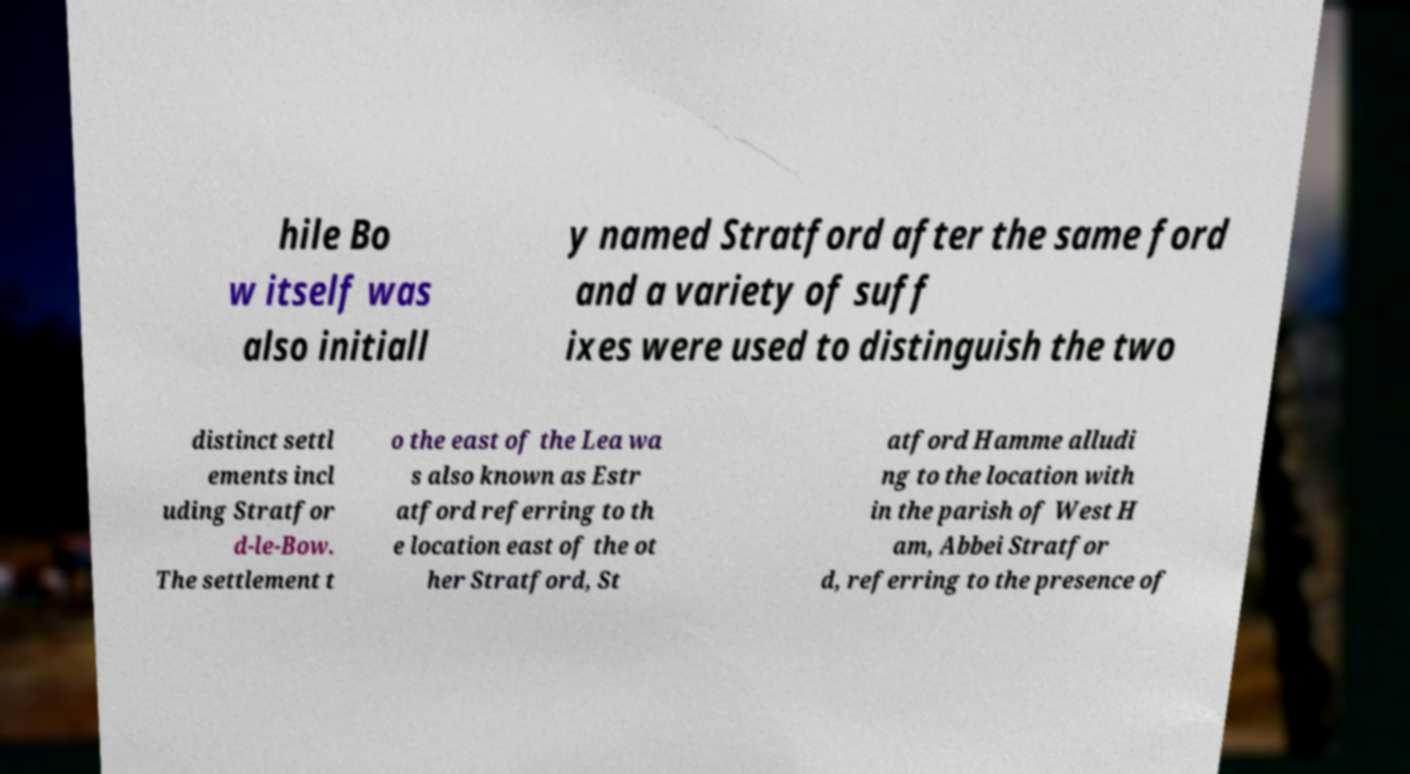There's text embedded in this image that I need extracted. Can you transcribe it verbatim? hile Bo w itself was also initiall y named Stratford after the same ford and a variety of suff ixes were used to distinguish the two distinct settl ements incl uding Stratfor d-le-Bow. The settlement t o the east of the Lea wa s also known as Estr atford referring to th e location east of the ot her Stratford, St atford Hamme alludi ng to the location with in the parish of West H am, Abbei Stratfor d, referring to the presence of 